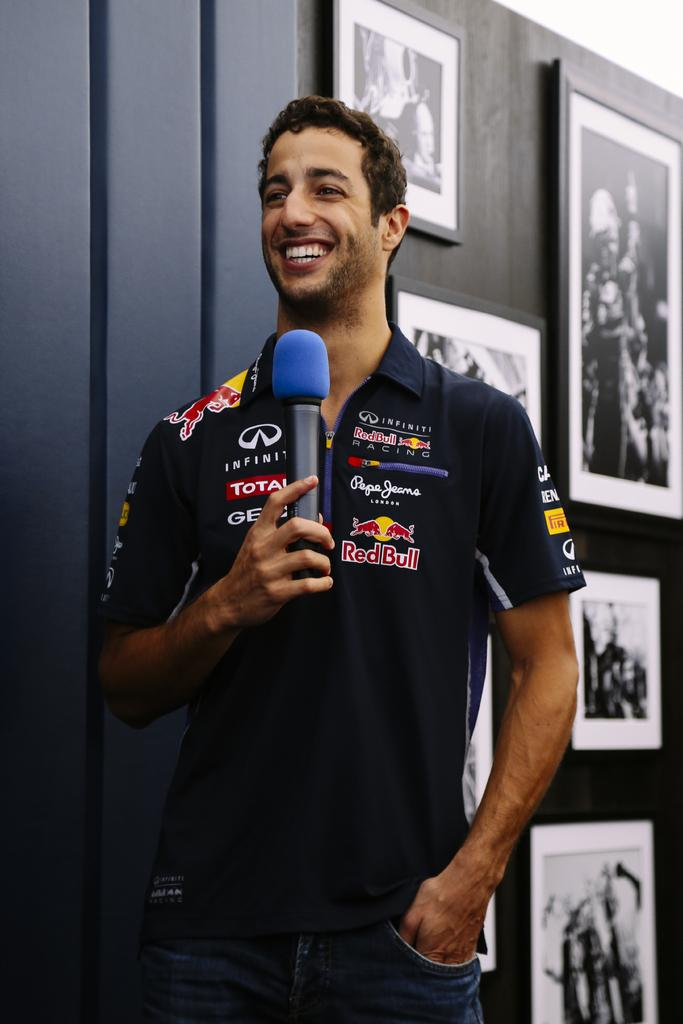<image>
Provide a brief description of the given image. A man is wearing a shirt that has sponsors's brand on it such as Red Bull, Infinity, and Pepe Geama 